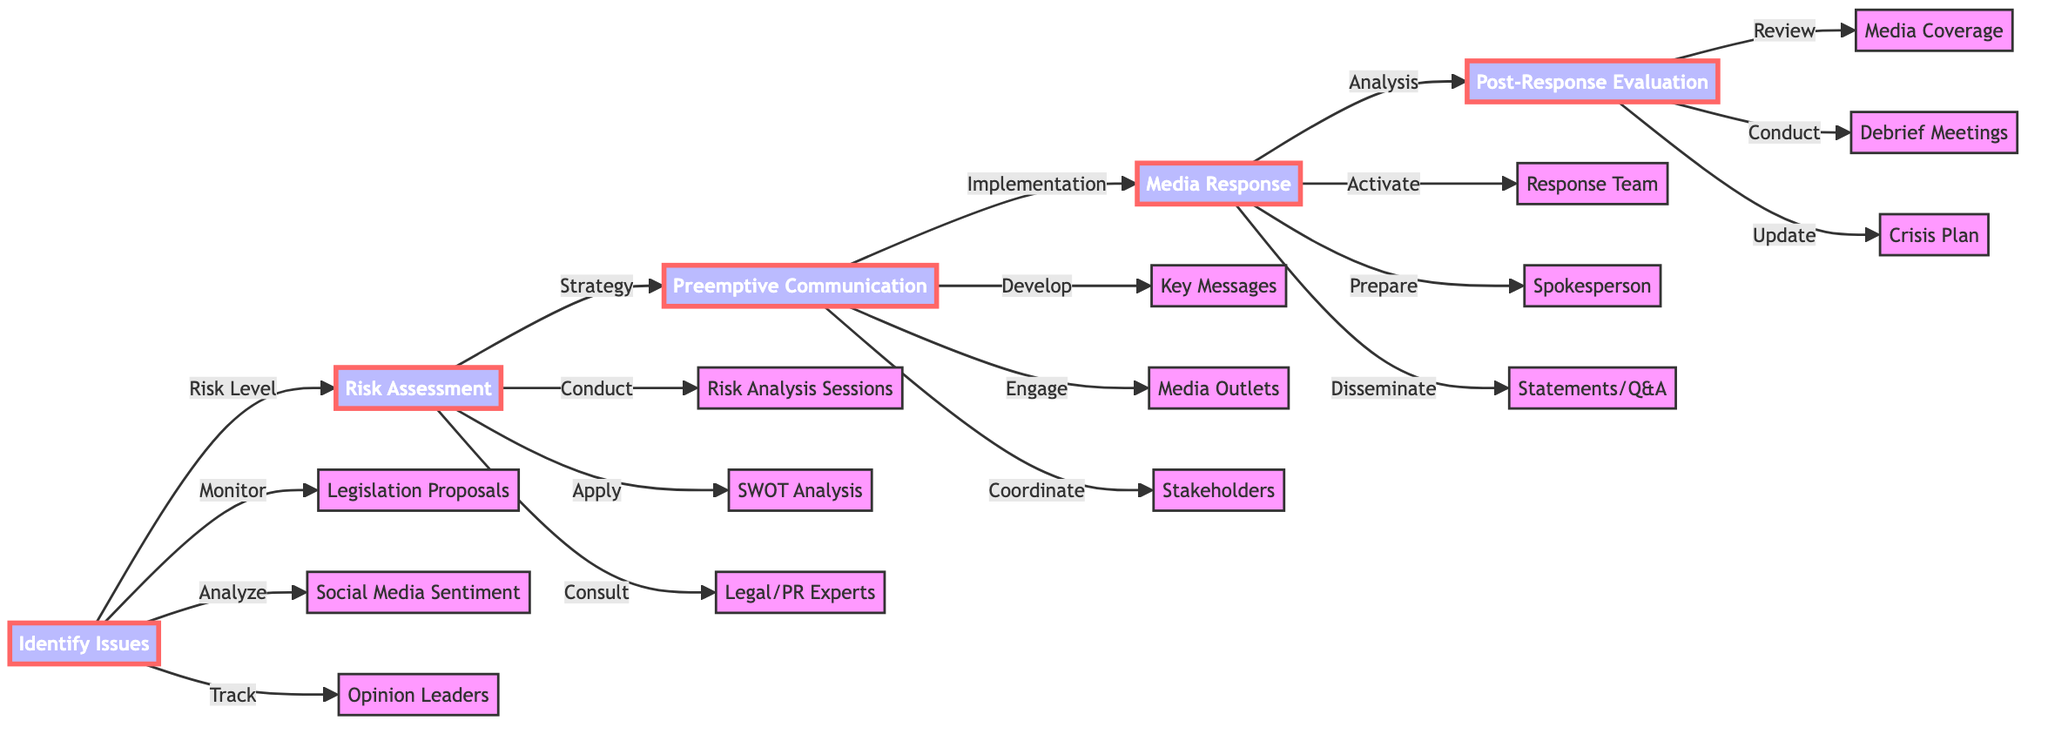What is the first step in the workflow? The diagram shows that the first step is labeled as "Identify Issues." This is the starting point of the crisis management workflow, indicating the initial action taken to address potential negative media attention.
Answer: Identify Issues How many main steps are there in the diagram? By reviewing the flowchart, one can count five main steps represented in the process: Identify Issues, Risk Assessment, Preemptive Communication, Media Response, and Post-Response Evaluation.
Answer: Five What action is performed during the "Media Response" step? The "Media Response" step has three related actions: activating the media response team, preparing the spokesperson with media training, and disseminating prepared statements and Q&A documents.
Answer: Activate media response team Which step comes after "Preemptive Communication"? The flowchart indicates that the step following "Preemptive Communication" is "Media Response," showing the order of operations in the crisis management workflow.
Answer: Media Response What type of analysis is suggested in the "Risk Assessment"? Within the "Risk Assessment" step, the diagram specifies that a SWOT analysis is one of the actions that should be performed, which helps to evaluate risks effectively.
Answer: SWOT analysis What is the final step in the crisis management workflow? Referring to the flowchart's structure, the last step in the sequence is "Post-Response Evaluation," which concludes the crisis management process with an assessment of the responses made.
Answer: Post-Response Evaluation What is monitored during the "Identify Issues" step? The diagram indicates three actions under "Identify Issues": monitoring legislation proposals, analyzing social media sentiment, and tracking opinion leaders, which are essential for identifying potential issues.
Answer: Legislation Proposals How does "Risk Assessment" relate to "Identify Issues"? The diagram illustrates that "Risk Assessment" is the next step following "Identify Issues," indicating that after identifying potential issues, an evaluation of the risk level and impact must be conducted.
Answer: Risk Assessment What type of team is activated during the "Media Response"? The "Media Response" step includes activating a media response team, which is crucial for managing interactions and communications with the media during a crisis.
Answer: Media response team 